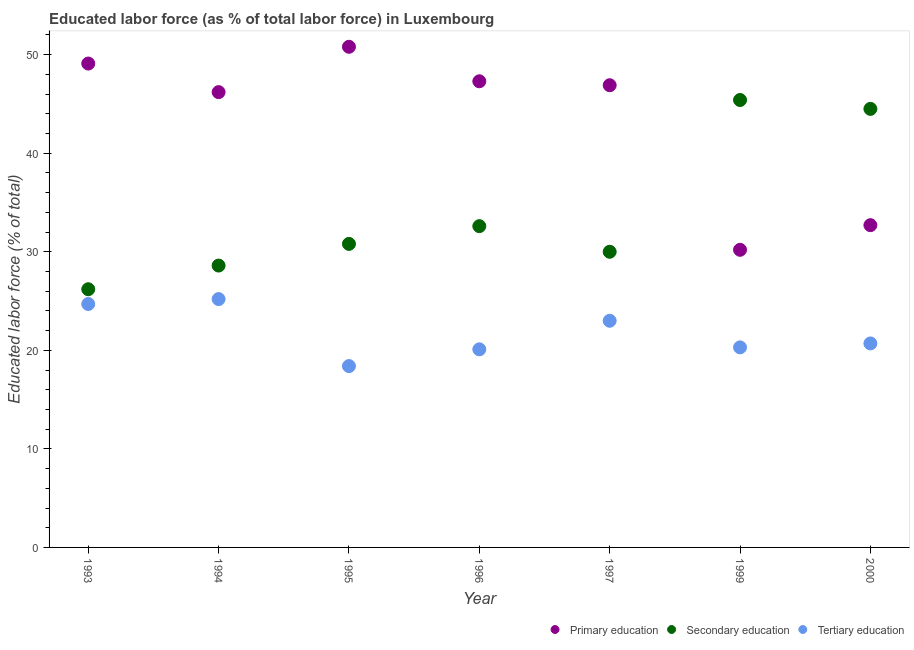How many different coloured dotlines are there?
Offer a terse response. 3. What is the percentage of labor force who received secondary education in 1996?
Your answer should be compact. 32.6. Across all years, what is the maximum percentage of labor force who received secondary education?
Your answer should be compact. 45.4. Across all years, what is the minimum percentage of labor force who received primary education?
Your answer should be very brief. 30.2. In which year was the percentage of labor force who received primary education minimum?
Your response must be concise. 1999. What is the total percentage of labor force who received secondary education in the graph?
Give a very brief answer. 238.1. What is the difference between the percentage of labor force who received tertiary education in 1995 and that in 2000?
Your response must be concise. -2.3. What is the difference between the percentage of labor force who received tertiary education in 1997 and the percentage of labor force who received secondary education in 2000?
Give a very brief answer. -21.5. What is the average percentage of labor force who received secondary education per year?
Give a very brief answer. 34.01. In the year 2000, what is the difference between the percentage of labor force who received secondary education and percentage of labor force who received tertiary education?
Give a very brief answer. 23.8. In how many years, is the percentage of labor force who received secondary education greater than 12 %?
Your answer should be very brief. 7. What is the ratio of the percentage of labor force who received secondary education in 1993 to that in 1994?
Your response must be concise. 0.92. Is the percentage of labor force who received primary education in 1994 less than that in 1995?
Offer a terse response. Yes. Is the difference between the percentage of labor force who received primary education in 1995 and 1996 greater than the difference between the percentage of labor force who received tertiary education in 1995 and 1996?
Offer a terse response. Yes. What is the difference between the highest and the second highest percentage of labor force who received tertiary education?
Your answer should be compact. 0.5. What is the difference between the highest and the lowest percentage of labor force who received tertiary education?
Provide a succinct answer. 6.8. Is the sum of the percentage of labor force who received secondary education in 1993 and 1997 greater than the maximum percentage of labor force who received primary education across all years?
Make the answer very short. Yes. Does the percentage of labor force who received tertiary education monotonically increase over the years?
Offer a very short reply. No. Is the percentage of labor force who received tertiary education strictly greater than the percentage of labor force who received secondary education over the years?
Your answer should be compact. No. How many legend labels are there?
Your answer should be very brief. 3. How are the legend labels stacked?
Your answer should be very brief. Horizontal. What is the title of the graph?
Offer a very short reply. Educated labor force (as % of total labor force) in Luxembourg. What is the label or title of the X-axis?
Provide a succinct answer. Year. What is the label or title of the Y-axis?
Offer a very short reply. Educated labor force (% of total). What is the Educated labor force (% of total) of Primary education in 1993?
Ensure brevity in your answer.  49.1. What is the Educated labor force (% of total) in Secondary education in 1993?
Your response must be concise. 26.2. What is the Educated labor force (% of total) of Tertiary education in 1993?
Offer a terse response. 24.7. What is the Educated labor force (% of total) in Primary education in 1994?
Offer a terse response. 46.2. What is the Educated labor force (% of total) in Secondary education in 1994?
Provide a succinct answer. 28.6. What is the Educated labor force (% of total) in Tertiary education in 1994?
Ensure brevity in your answer.  25.2. What is the Educated labor force (% of total) in Primary education in 1995?
Your response must be concise. 50.8. What is the Educated labor force (% of total) in Secondary education in 1995?
Keep it short and to the point. 30.8. What is the Educated labor force (% of total) of Tertiary education in 1995?
Provide a succinct answer. 18.4. What is the Educated labor force (% of total) of Primary education in 1996?
Provide a succinct answer. 47.3. What is the Educated labor force (% of total) in Secondary education in 1996?
Offer a terse response. 32.6. What is the Educated labor force (% of total) in Tertiary education in 1996?
Provide a succinct answer. 20.1. What is the Educated labor force (% of total) in Primary education in 1997?
Your answer should be very brief. 46.9. What is the Educated labor force (% of total) in Secondary education in 1997?
Your answer should be compact. 30. What is the Educated labor force (% of total) in Primary education in 1999?
Ensure brevity in your answer.  30.2. What is the Educated labor force (% of total) in Secondary education in 1999?
Make the answer very short. 45.4. What is the Educated labor force (% of total) in Tertiary education in 1999?
Keep it short and to the point. 20.3. What is the Educated labor force (% of total) of Primary education in 2000?
Your answer should be compact. 32.7. What is the Educated labor force (% of total) in Secondary education in 2000?
Your answer should be very brief. 44.5. What is the Educated labor force (% of total) of Tertiary education in 2000?
Give a very brief answer. 20.7. Across all years, what is the maximum Educated labor force (% of total) of Primary education?
Provide a succinct answer. 50.8. Across all years, what is the maximum Educated labor force (% of total) of Secondary education?
Your answer should be very brief. 45.4. Across all years, what is the maximum Educated labor force (% of total) in Tertiary education?
Ensure brevity in your answer.  25.2. Across all years, what is the minimum Educated labor force (% of total) in Primary education?
Provide a succinct answer. 30.2. Across all years, what is the minimum Educated labor force (% of total) of Secondary education?
Your answer should be compact. 26.2. Across all years, what is the minimum Educated labor force (% of total) in Tertiary education?
Your answer should be compact. 18.4. What is the total Educated labor force (% of total) of Primary education in the graph?
Offer a very short reply. 303.2. What is the total Educated labor force (% of total) in Secondary education in the graph?
Keep it short and to the point. 238.1. What is the total Educated labor force (% of total) of Tertiary education in the graph?
Give a very brief answer. 152.4. What is the difference between the Educated labor force (% of total) in Secondary education in 1993 and that in 1994?
Your answer should be very brief. -2.4. What is the difference between the Educated labor force (% of total) in Primary education in 1993 and that in 1995?
Your response must be concise. -1.7. What is the difference between the Educated labor force (% of total) of Secondary education in 1993 and that in 1995?
Provide a short and direct response. -4.6. What is the difference between the Educated labor force (% of total) of Primary education in 1993 and that in 1996?
Give a very brief answer. 1.8. What is the difference between the Educated labor force (% of total) of Secondary education in 1993 and that in 1996?
Your answer should be compact. -6.4. What is the difference between the Educated labor force (% of total) of Tertiary education in 1993 and that in 1996?
Your response must be concise. 4.6. What is the difference between the Educated labor force (% of total) of Primary education in 1993 and that in 1999?
Ensure brevity in your answer.  18.9. What is the difference between the Educated labor force (% of total) in Secondary education in 1993 and that in 1999?
Your answer should be compact. -19.2. What is the difference between the Educated labor force (% of total) in Tertiary education in 1993 and that in 1999?
Your answer should be very brief. 4.4. What is the difference between the Educated labor force (% of total) in Primary education in 1993 and that in 2000?
Make the answer very short. 16.4. What is the difference between the Educated labor force (% of total) of Secondary education in 1993 and that in 2000?
Your answer should be compact. -18.3. What is the difference between the Educated labor force (% of total) in Tertiary education in 1993 and that in 2000?
Your answer should be compact. 4. What is the difference between the Educated labor force (% of total) of Primary education in 1994 and that in 1995?
Give a very brief answer. -4.6. What is the difference between the Educated labor force (% of total) in Secondary education in 1994 and that in 1995?
Your response must be concise. -2.2. What is the difference between the Educated labor force (% of total) of Tertiary education in 1994 and that in 1996?
Provide a short and direct response. 5.1. What is the difference between the Educated labor force (% of total) in Primary education in 1994 and that in 1997?
Ensure brevity in your answer.  -0.7. What is the difference between the Educated labor force (% of total) in Tertiary education in 1994 and that in 1997?
Provide a short and direct response. 2.2. What is the difference between the Educated labor force (% of total) in Primary education in 1994 and that in 1999?
Ensure brevity in your answer.  16. What is the difference between the Educated labor force (% of total) in Secondary education in 1994 and that in 1999?
Your answer should be very brief. -16.8. What is the difference between the Educated labor force (% of total) in Primary education in 1994 and that in 2000?
Your answer should be compact. 13.5. What is the difference between the Educated labor force (% of total) in Secondary education in 1994 and that in 2000?
Give a very brief answer. -15.9. What is the difference between the Educated labor force (% of total) of Primary education in 1995 and that in 1996?
Your answer should be compact. 3.5. What is the difference between the Educated labor force (% of total) of Tertiary education in 1995 and that in 1996?
Provide a short and direct response. -1.7. What is the difference between the Educated labor force (% of total) of Primary education in 1995 and that in 1997?
Give a very brief answer. 3.9. What is the difference between the Educated labor force (% of total) of Primary education in 1995 and that in 1999?
Make the answer very short. 20.6. What is the difference between the Educated labor force (% of total) of Secondary education in 1995 and that in 1999?
Offer a terse response. -14.6. What is the difference between the Educated labor force (% of total) in Tertiary education in 1995 and that in 1999?
Ensure brevity in your answer.  -1.9. What is the difference between the Educated labor force (% of total) in Secondary education in 1995 and that in 2000?
Your answer should be compact. -13.7. What is the difference between the Educated labor force (% of total) of Secondary education in 1996 and that in 1997?
Your answer should be very brief. 2.6. What is the difference between the Educated labor force (% of total) of Primary education in 1996 and that in 1999?
Your answer should be compact. 17.1. What is the difference between the Educated labor force (% of total) in Secondary education in 1997 and that in 1999?
Ensure brevity in your answer.  -15.4. What is the difference between the Educated labor force (% of total) of Tertiary education in 1997 and that in 1999?
Offer a very short reply. 2.7. What is the difference between the Educated labor force (% of total) in Primary education in 1997 and that in 2000?
Provide a short and direct response. 14.2. What is the difference between the Educated labor force (% of total) of Secondary education in 1997 and that in 2000?
Ensure brevity in your answer.  -14.5. What is the difference between the Educated labor force (% of total) in Tertiary education in 1997 and that in 2000?
Provide a succinct answer. 2.3. What is the difference between the Educated labor force (% of total) of Tertiary education in 1999 and that in 2000?
Ensure brevity in your answer.  -0.4. What is the difference between the Educated labor force (% of total) in Primary education in 1993 and the Educated labor force (% of total) in Secondary education in 1994?
Your response must be concise. 20.5. What is the difference between the Educated labor force (% of total) in Primary education in 1993 and the Educated labor force (% of total) in Tertiary education in 1994?
Your answer should be very brief. 23.9. What is the difference between the Educated labor force (% of total) in Primary education in 1993 and the Educated labor force (% of total) in Secondary education in 1995?
Provide a short and direct response. 18.3. What is the difference between the Educated labor force (% of total) of Primary education in 1993 and the Educated labor force (% of total) of Tertiary education in 1995?
Ensure brevity in your answer.  30.7. What is the difference between the Educated labor force (% of total) of Secondary education in 1993 and the Educated labor force (% of total) of Tertiary education in 1996?
Offer a very short reply. 6.1. What is the difference between the Educated labor force (% of total) of Primary education in 1993 and the Educated labor force (% of total) of Secondary education in 1997?
Provide a short and direct response. 19.1. What is the difference between the Educated labor force (% of total) of Primary education in 1993 and the Educated labor force (% of total) of Tertiary education in 1997?
Provide a succinct answer. 26.1. What is the difference between the Educated labor force (% of total) in Secondary education in 1993 and the Educated labor force (% of total) in Tertiary education in 1997?
Your answer should be very brief. 3.2. What is the difference between the Educated labor force (% of total) in Primary education in 1993 and the Educated labor force (% of total) in Secondary education in 1999?
Give a very brief answer. 3.7. What is the difference between the Educated labor force (% of total) of Primary education in 1993 and the Educated labor force (% of total) of Tertiary education in 1999?
Offer a terse response. 28.8. What is the difference between the Educated labor force (% of total) of Primary education in 1993 and the Educated labor force (% of total) of Tertiary education in 2000?
Provide a short and direct response. 28.4. What is the difference between the Educated labor force (% of total) of Primary education in 1994 and the Educated labor force (% of total) of Tertiary education in 1995?
Your answer should be very brief. 27.8. What is the difference between the Educated labor force (% of total) of Secondary education in 1994 and the Educated labor force (% of total) of Tertiary education in 1995?
Keep it short and to the point. 10.2. What is the difference between the Educated labor force (% of total) in Primary education in 1994 and the Educated labor force (% of total) in Tertiary education in 1996?
Provide a short and direct response. 26.1. What is the difference between the Educated labor force (% of total) in Secondary education in 1994 and the Educated labor force (% of total) in Tertiary education in 1996?
Keep it short and to the point. 8.5. What is the difference between the Educated labor force (% of total) in Primary education in 1994 and the Educated labor force (% of total) in Tertiary education in 1997?
Your response must be concise. 23.2. What is the difference between the Educated labor force (% of total) of Primary education in 1994 and the Educated labor force (% of total) of Tertiary education in 1999?
Your answer should be very brief. 25.9. What is the difference between the Educated labor force (% of total) of Secondary education in 1994 and the Educated labor force (% of total) of Tertiary education in 1999?
Give a very brief answer. 8.3. What is the difference between the Educated labor force (% of total) of Primary education in 1994 and the Educated labor force (% of total) of Secondary education in 2000?
Your response must be concise. 1.7. What is the difference between the Educated labor force (% of total) of Primary education in 1994 and the Educated labor force (% of total) of Tertiary education in 2000?
Keep it short and to the point. 25.5. What is the difference between the Educated labor force (% of total) of Primary education in 1995 and the Educated labor force (% of total) of Tertiary education in 1996?
Give a very brief answer. 30.7. What is the difference between the Educated labor force (% of total) in Secondary education in 1995 and the Educated labor force (% of total) in Tertiary education in 1996?
Keep it short and to the point. 10.7. What is the difference between the Educated labor force (% of total) in Primary education in 1995 and the Educated labor force (% of total) in Secondary education in 1997?
Offer a terse response. 20.8. What is the difference between the Educated labor force (% of total) in Primary education in 1995 and the Educated labor force (% of total) in Tertiary education in 1997?
Offer a very short reply. 27.8. What is the difference between the Educated labor force (% of total) of Secondary education in 1995 and the Educated labor force (% of total) of Tertiary education in 1997?
Offer a terse response. 7.8. What is the difference between the Educated labor force (% of total) of Primary education in 1995 and the Educated labor force (% of total) of Secondary education in 1999?
Give a very brief answer. 5.4. What is the difference between the Educated labor force (% of total) of Primary education in 1995 and the Educated labor force (% of total) of Tertiary education in 1999?
Your response must be concise. 30.5. What is the difference between the Educated labor force (% of total) of Secondary education in 1995 and the Educated labor force (% of total) of Tertiary education in 1999?
Offer a very short reply. 10.5. What is the difference between the Educated labor force (% of total) in Primary education in 1995 and the Educated labor force (% of total) in Secondary education in 2000?
Make the answer very short. 6.3. What is the difference between the Educated labor force (% of total) in Primary education in 1995 and the Educated labor force (% of total) in Tertiary education in 2000?
Keep it short and to the point. 30.1. What is the difference between the Educated labor force (% of total) in Primary education in 1996 and the Educated labor force (% of total) in Tertiary education in 1997?
Provide a short and direct response. 24.3. What is the difference between the Educated labor force (% of total) of Secondary education in 1996 and the Educated labor force (% of total) of Tertiary education in 1997?
Keep it short and to the point. 9.6. What is the difference between the Educated labor force (% of total) in Primary education in 1996 and the Educated labor force (% of total) in Secondary education in 1999?
Provide a short and direct response. 1.9. What is the difference between the Educated labor force (% of total) in Secondary education in 1996 and the Educated labor force (% of total) in Tertiary education in 1999?
Offer a very short reply. 12.3. What is the difference between the Educated labor force (% of total) in Primary education in 1996 and the Educated labor force (% of total) in Tertiary education in 2000?
Offer a terse response. 26.6. What is the difference between the Educated labor force (% of total) of Primary education in 1997 and the Educated labor force (% of total) of Secondary education in 1999?
Your answer should be compact. 1.5. What is the difference between the Educated labor force (% of total) in Primary education in 1997 and the Educated labor force (% of total) in Tertiary education in 1999?
Ensure brevity in your answer.  26.6. What is the difference between the Educated labor force (% of total) in Primary education in 1997 and the Educated labor force (% of total) in Tertiary education in 2000?
Ensure brevity in your answer.  26.2. What is the difference between the Educated labor force (% of total) in Primary education in 1999 and the Educated labor force (% of total) in Secondary education in 2000?
Offer a terse response. -14.3. What is the difference between the Educated labor force (% of total) in Primary education in 1999 and the Educated labor force (% of total) in Tertiary education in 2000?
Provide a succinct answer. 9.5. What is the difference between the Educated labor force (% of total) of Secondary education in 1999 and the Educated labor force (% of total) of Tertiary education in 2000?
Your answer should be compact. 24.7. What is the average Educated labor force (% of total) in Primary education per year?
Keep it short and to the point. 43.31. What is the average Educated labor force (% of total) of Secondary education per year?
Your response must be concise. 34.01. What is the average Educated labor force (% of total) of Tertiary education per year?
Provide a short and direct response. 21.77. In the year 1993, what is the difference between the Educated labor force (% of total) of Primary education and Educated labor force (% of total) of Secondary education?
Offer a terse response. 22.9. In the year 1993, what is the difference between the Educated labor force (% of total) in Primary education and Educated labor force (% of total) in Tertiary education?
Your answer should be very brief. 24.4. In the year 1993, what is the difference between the Educated labor force (% of total) of Secondary education and Educated labor force (% of total) of Tertiary education?
Your response must be concise. 1.5. In the year 1994, what is the difference between the Educated labor force (% of total) of Secondary education and Educated labor force (% of total) of Tertiary education?
Your response must be concise. 3.4. In the year 1995, what is the difference between the Educated labor force (% of total) of Primary education and Educated labor force (% of total) of Tertiary education?
Offer a terse response. 32.4. In the year 1995, what is the difference between the Educated labor force (% of total) of Secondary education and Educated labor force (% of total) of Tertiary education?
Make the answer very short. 12.4. In the year 1996, what is the difference between the Educated labor force (% of total) in Primary education and Educated labor force (% of total) in Secondary education?
Ensure brevity in your answer.  14.7. In the year 1996, what is the difference between the Educated labor force (% of total) of Primary education and Educated labor force (% of total) of Tertiary education?
Make the answer very short. 27.2. In the year 1996, what is the difference between the Educated labor force (% of total) of Secondary education and Educated labor force (% of total) of Tertiary education?
Offer a terse response. 12.5. In the year 1997, what is the difference between the Educated labor force (% of total) in Primary education and Educated labor force (% of total) in Secondary education?
Provide a succinct answer. 16.9. In the year 1997, what is the difference between the Educated labor force (% of total) of Primary education and Educated labor force (% of total) of Tertiary education?
Offer a terse response. 23.9. In the year 1997, what is the difference between the Educated labor force (% of total) of Secondary education and Educated labor force (% of total) of Tertiary education?
Your answer should be very brief. 7. In the year 1999, what is the difference between the Educated labor force (% of total) in Primary education and Educated labor force (% of total) in Secondary education?
Provide a succinct answer. -15.2. In the year 1999, what is the difference between the Educated labor force (% of total) in Primary education and Educated labor force (% of total) in Tertiary education?
Ensure brevity in your answer.  9.9. In the year 1999, what is the difference between the Educated labor force (% of total) of Secondary education and Educated labor force (% of total) of Tertiary education?
Provide a succinct answer. 25.1. In the year 2000, what is the difference between the Educated labor force (% of total) in Primary education and Educated labor force (% of total) in Tertiary education?
Give a very brief answer. 12. In the year 2000, what is the difference between the Educated labor force (% of total) of Secondary education and Educated labor force (% of total) of Tertiary education?
Keep it short and to the point. 23.8. What is the ratio of the Educated labor force (% of total) in Primary education in 1993 to that in 1994?
Keep it short and to the point. 1.06. What is the ratio of the Educated labor force (% of total) in Secondary education in 1993 to that in 1994?
Your answer should be very brief. 0.92. What is the ratio of the Educated labor force (% of total) in Tertiary education in 1993 to that in 1994?
Your response must be concise. 0.98. What is the ratio of the Educated labor force (% of total) in Primary education in 1993 to that in 1995?
Your response must be concise. 0.97. What is the ratio of the Educated labor force (% of total) in Secondary education in 1993 to that in 1995?
Keep it short and to the point. 0.85. What is the ratio of the Educated labor force (% of total) of Tertiary education in 1993 to that in 1995?
Your answer should be very brief. 1.34. What is the ratio of the Educated labor force (% of total) of Primary education in 1993 to that in 1996?
Keep it short and to the point. 1.04. What is the ratio of the Educated labor force (% of total) of Secondary education in 1993 to that in 1996?
Provide a succinct answer. 0.8. What is the ratio of the Educated labor force (% of total) of Tertiary education in 1993 to that in 1996?
Offer a terse response. 1.23. What is the ratio of the Educated labor force (% of total) of Primary education in 1993 to that in 1997?
Your answer should be compact. 1.05. What is the ratio of the Educated labor force (% of total) in Secondary education in 1993 to that in 1997?
Keep it short and to the point. 0.87. What is the ratio of the Educated labor force (% of total) in Tertiary education in 1993 to that in 1997?
Give a very brief answer. 1.07. What is the ratio of the Educated labor force (% of total) in Primary education in 1993 to that in 1999?
Make the answer very short. 1.63. What is the ratio of the Educated labor force (% of total) of Secondary education in 1993 to that in 1999?
Give a very brief answer. 0.58. What is the ratio of the Educated labor force (% of total) of Tertiary education in 1993 to that in 1999?
Your response must be concise. 1.22. What is the ratio of the Educated labor force (% of total) in Primary education in 1993 to that in 2000?
Provide a short and direct response. 1.5. What is the ratio of the Educated labor force (% of total) in Secondary education in 1993 to that in 2000?
Your response must be concise. 0.59. What is the ratio of the Educated labor force (% of total) of Tertiary education in 1993 to that in 2000?
Provide a short and direct response. 1.19. What is the ratio of the Educated labor force (% of total) of Primary education in 1994 to that in 1995?
Make the answer very short. 0.91. What is the ratio of the Educated labor force (% of total) of Tertiary education in 1994 to that in 1995?
Make the answer very short. 1.37. What is the ratio of the Educated labor force (% of total) of Primary education in 1994 to that in 1996?
Offer a terse response. 0.98. What is the ratio of the Educated labor force (% of total) in Secondary education in 1994 to that in 1996?
Your answer should be very brief. 0.88. What is the ratio of the Educated labor force (% of total) in Tertiary education in 1994 to that in 1996?
Provide a succinct answer. 1.25. What is the ratio of the Educated labor force (% of total) in Primary education in 1994 to that in 1997?
Provide a succinct answer. 0.99. What is the ratio of the Educated labor force (% of total) in Secondary education in 1994 to that in 1997?
Ensure brevity in your answer.  0.95. What is the ratio of the Educated labor force (% of total) in Tertiary education in 1994 to that in 1997?
Offer a terse response. 1.1. What is the ratio of the Educated labor force (% of total) of Primary education in 1994 to that in 1999?
Provide a short and direct response. 1.53. What is the ratio of the Educated labor force (% of total) of Secondary education in 1994 to that in 1999?
Offer a very short reply. 0.63. What is the ratio of the Educated labor force (% of total) of Tertiary education in 1994 to that in 1999?
Provide a succinct answer. 1.24. What is the ratio of the Educated labor force (% of total) of Primary education in 1994 to that in 2000?
Give a very brief answer. 1.41. What is the ratio of the Educated labor force (% of total) in Secondary education in 1994 to that in 2000?
Ensure brevity in your answer.  0.64. What is the ratio of the Educated labor force (% of total) in Tertiary education in 1994 to that in 2000?
Give a very brief answer. 1.22. What is the ratio of the Educated labor force (% of total) of Primary education in 1995 to that in 1996?
Your answer should be very brief. 1.07. What is the ratio of the Educated labor force (% of total) of Secondary education in 1995 to that in 1996?
Your response must be concise. 0.94. What is the ratio of the Educated labor force (% of total) in Tertiary education in 1995 to that in 1996?
Give a very brief answer. 0.92. What is the ratio of the Educated labor force (% of total) of Primary education in 1995 to that in 1997?
Provide a succinct answer. 1.08. What is the ratio of the Educated labor force (% of total) of Secondary education in 1995 to that in 1997?
Make the answer very short. 1.03. What is the ratio of the Educated labor force (% of total) in Primary education in 1995 to that in 1999?
Your answer should be very brief. 1.68. What is the ratio of the Educated labor force (% of total) of Secondary education in 1995 to that in 1999?
Give a very brief answer. 0.68. What is the ratio of the Educated labor force (% of total) of Tertiary education in 1995 to that in 1999?
Ensure brevity in your answer.  0.91. What is the ratio of the Educated labor force (% of total) of Primary education in 1995 to that in 2000?
Keep it short and to the point. 1.55. What is the ratio of the Educated labor force (% of total) in Secondary education in 1995 to that in 2000?
Provide a short and direct response. 0.69. What is the ratio of the Educated labor force (% of total) in Primary education in 1996 to that in 1997?
Give a very brief answer. 1.01. What is the ratio of the Educated labor force (% of total) of Secondary education in 1996 to that in 1997?
Keep it short and to the point. 1.09. What is the ratio of the Educated labor force (% of total) in Tertiary education in 1996 to that in 1997?
Your answer should be compact. 0.87. What is the ratio of the Educated labor force (% of total) of Primary education in 1996 to that in 1999?
Your response must be concise. 1.57. What is the ratio of the Educated labor force (% of total) in Secondary education in 1996 to that in 1999?
Offer a terse response. 0.72. What is the ratio of the Educated labor force (% of total) of Tertiary education in 1996 to that in 1999?
Offer a very short reply. 0.99. What is the ratio of the Educated labor force (% of total) of Primary education in 1996 to that in 2000?
Offer a very short reply. 1.45. What is the ratio of the Educated labor force (% of total) in Secondary education in 1996 to that in 2000?
Your answer should be very brief. 0.73. What is the ratio of the Educated labor force (% of total) in Tertiary education in 1996 to that in 2000?
Offer a very short reply. 0.97. What is the ratio of the Educated labor force (% of total) in Primary education in 1997 to that in 1999?
Your response must be concise. 1.55. What is the ratio of the Educated labor force (% of total) of Secondary education in 1997 to that in 1999?
Keep it short and to the point. 0.66. What is the ratio of the Educated labor force (% of total) in Tertiary education in 1997 to that in 1999?
Offer a very short reply. 1.13. What is the ratio of the Educated labor force (% of total) of Primary education in 1997 to that in 2000?
Your answer should be very brief. 1.43. What is the ratio of the Educated labor force (% of total) in Secondary education in 1997 to that in 2000?
Ensure brevity in your answer.  0.67. What is the ratio of the Educated labor force (% of total) in Primary education in 1999 to that in 2000?
Make the answer very short. 0.92. What is the ratio of the Educated labor force (% of total) of Secondary education in 1999 to that in 2000?
Your answer should be compact. 1.02. What is the ratio of the Educated labor force (% of total) in Tertiary education in 1999 to that in 2000?
Give a very brief answer. 0.98. What is the difference between the highest and the second highest Educated labor force (% of total) of Primary education?
Offer a very short reply. 1.7. What is the difference between the highest and the second highest Educated labor force (% of total) of Secondary education?
Your answer should be very brief. 0.9. What is the difference between the highest and the second highest Educated labor force (% of total) in Tertiary education?
Make the answer very short. 0.5. What is the difference between the highest and the lowest Educated labor force (% of total) of Primary education?
Make the answer very short. 20.6. 